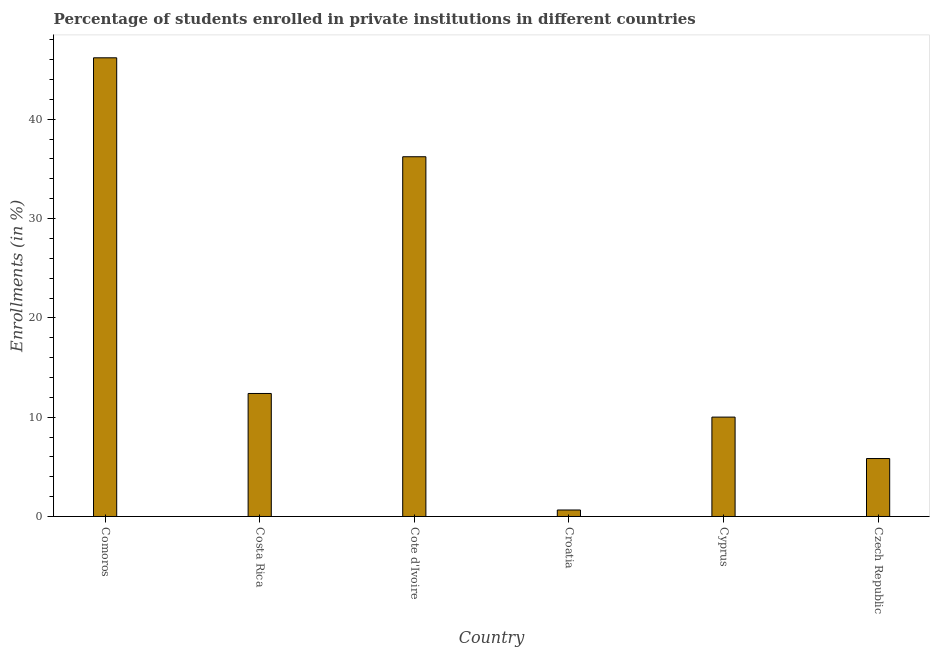What is the title of the graph?
Make the answer very short. Percentage of students enrolled in private institutions in different countries. What is the label or title of the X-axis?
Make the answer very short. Country. What is the label or title of the Y-axis?
Make the answer very short. Enrollments (in %). What is the enrollments in private institutions in Costa Rica?
Keep it short and to the point. 12.39. Across all countries, what is the maximum enrollments in private institutions?
Ensure brevity in your answer.  46.19. Across all countries, what is the minimum enrollments in private institutions?
Your answer should be compact. 0.65. In which country was the enrollments in private institutions maximum?
Keep it short and to the point. Comoros. In which country was the enrollments in private institutions minimum?
Ensure brevity in your answer.  Croatia. What is the sum of the enrollments in private institutions?
Offer a terse response. 111.3. What is the difference between the enrollments in private institutions in Comoros and Cote d'Ivoire?
Provide a succinct answer. 9.96. What is the average enrollments in private institutions per country?
Offer a terse response. 18.55. What is the median enrollments in private institutions?
Keep it short and to the point. 11.2. In how many countries, is the enrollments in private institutions greater than 14 %?
Provide a short and direct response. 2. What is the ratio of the enrollments in private institutions in Croatia to that in Cyprus?
Provide a short and direct response. 0.07. What is the difference between the highest and the second highest enrollments in private institutions?
Your response must be concise. 9.96. What is the difference between the highest and the lowest enrollments in private institutions?
Provide a short and direct response. 45.53. What is the difference between two consecutive major ticks on the Y-axis?
Offer a terse response. 10. Are the values on the major ticks of Y-axis written in scientific E-notation?
Ensure brevity in your answer.  No. What is the Enrollments (in %) of Comoros?
Your answer should be very brief. 46.19. What is the Enrollments (in %) of Costa Rica?
Keep it short and to the point. 12.39. What is the Enrollments (in %) of Cote d'Ivoire?
Give a very brief answer. 36.23. What is the Enrollments (in %) of Croatia?
Provide a short and direct response. 0.65. What is the Enrollments (in %) of Cyprus?
Make the answer very short. 10.01. What is the Enrollments (in %) in Czech Republic?
Give a very brief answer. 5.83. What is the difference between the Enrollments (in %) in Comoros and Costa Rica?
Ensure brevity in your answer.  33.8. What is the difference between the Enrollments (in %) in Comoros and Cote d'Ivoire?
Offer a terse response. 9.96. What is the difference between the Enrollments (in %) in Comoros and Croatia?
Your response must be concise. 45.53. What is the difference between the Enrollments (in %) in Comoros and Cyprus?
Your answer should be very brief. 36.18. What is the difference between the Enrollments (in %) in Comoros and Czech Republic?
Provide a succinct answer. 40.35. What is the difference between the Enrollments (in %) in Costa Rica and Cote d'Ivoire?
Your answer should be very brief. -23.84. What is the difference between the Enrollments (in %) in Costa Rica and Croatia?
Provide a succinct answer. 11.73. What is the difference between the Enrollments (in %) in Costa Rica and Cyprus?
Your response must be concise. 2.38. What is the difference between the Enrollments (in %) in Costa Rica and Czech Republic?
Give a very brief answer. 6.55. What is the difference between the Enrollments (in %) in Cote d'Ivoire and Croatia?
Your response must be concise. 35.57. What is the difference between the Enrollments (in %) in Cote d'Ivoire and Cyprus?
Make the answer very short. 26.22. What is the difference between the Enrollments (in %) in Cote d'Ivoire and Czech Republic?
Your answer should be compact. 30.39. What is the difference between the Enrollments (in %) in Croatia and Cyprus?
Give a very brief answer. -9.35. What is the difference between the Enrollments (in %) in Croatia and Czech Republic?
Provide a succinct answer. -5.18. What is the difference between the Enrollments (in %) in Cyprus and Czech Republic?
Offer a terse response. 4.17. What is the ratio of the Enrollments (in %) in Comoros to that in Costa Rica?
Offer a very short reply. 3.73. What is the ratio of the Enrollments (in %) in Comoros to that in Cote d'Ivoire?
Make the answer very short. 1.27. What is the ratio of the Enrollments (in %) in Comoros to that in Croatia?
Your response must be concise. 70.65. What is the ratio of the Enrollments (in %) in Comoros to that in Cyprus?
Offer a very short reply. 4.62. What is the ratio of the Enrollments (in %) in Comoros to that in Czech Republic?
Your answer should be very brief. 7.92. What is the ratio of the Enrollments (in %) in Costa Rica to that in Cote d'Ivoire?
Provide a succinct answer. 0.34. What is the ratio of the Enrollments (in %) in Costa Rica to that in Croatia?
Your answer should be compact. 18.95. What is the ratio of the Enrollments (in %) in Costa Rica to that in Cyprus?
Make the answer very short. 1.24. What is the ratio of the Enrollments (in %) in Costa Rica to that in Czech Republic?
Your answer should be very brief. 2.12. What is the ratio of the Enrollments (in %) in Cote d'Ivoire to that in Croatia?
Offer a very short reply. 55.41. What is the ratio of the Enrollments (in %) in Cote d'Ivoire to that in Cyprus?
Provide a short and direct response. 3.62. What is the ratio of the Enrollments (in %) in Cote d'Ivoire to that in Czech Republic?
Offer a very short reply. 6.21. What is the ratio of the Enrollments (in %) in Croatia to that in Cyprus?
Give a very brief answer. 0.07. What is the ratio of the Enrollments (in %) in Croatia to that in Czech Republic?
Provide a short and direct response. 0.11. What is the ratio of the Enrollments (in %) in Cyprus to that in Czech Republic?
Offer a very short reply. 1.72. 